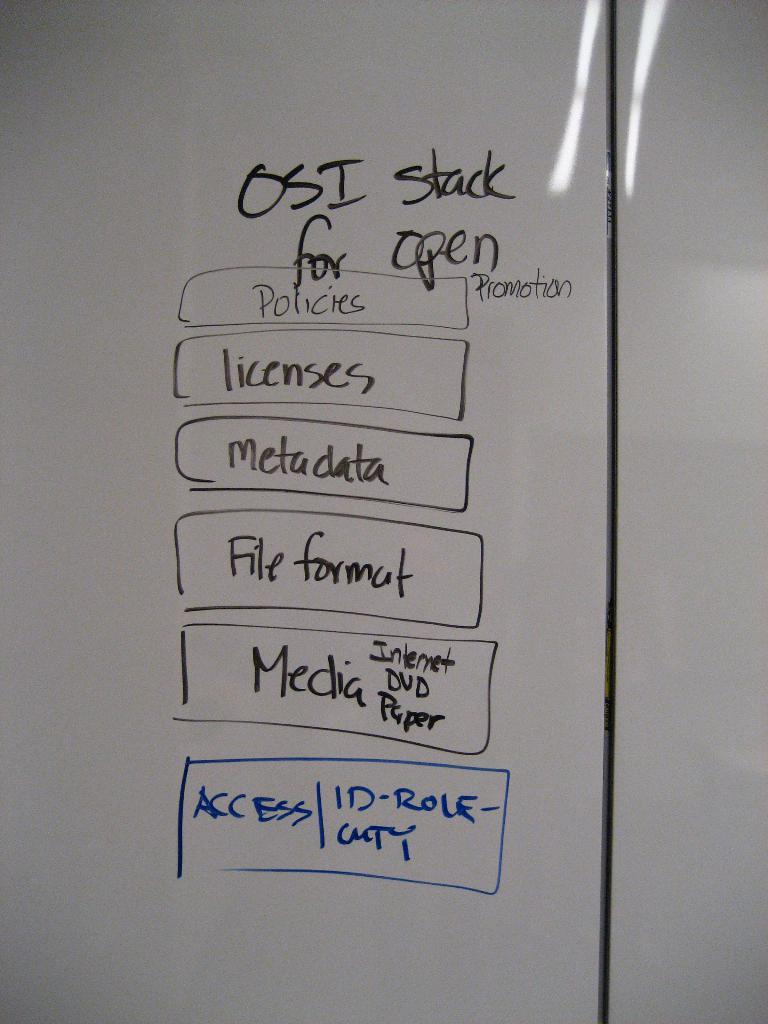<image>
Share a concise interpretation of the image provided. A dry erase board details the OSI stack for open flow. 